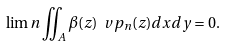Convert formula to latex. <formula><loc_0><loc_0><loc_500><loc_500>\lim n \iint _ { A } \beta ( z ) \ v p _ { n } ( z ) d x d y = 0 .</formula> 